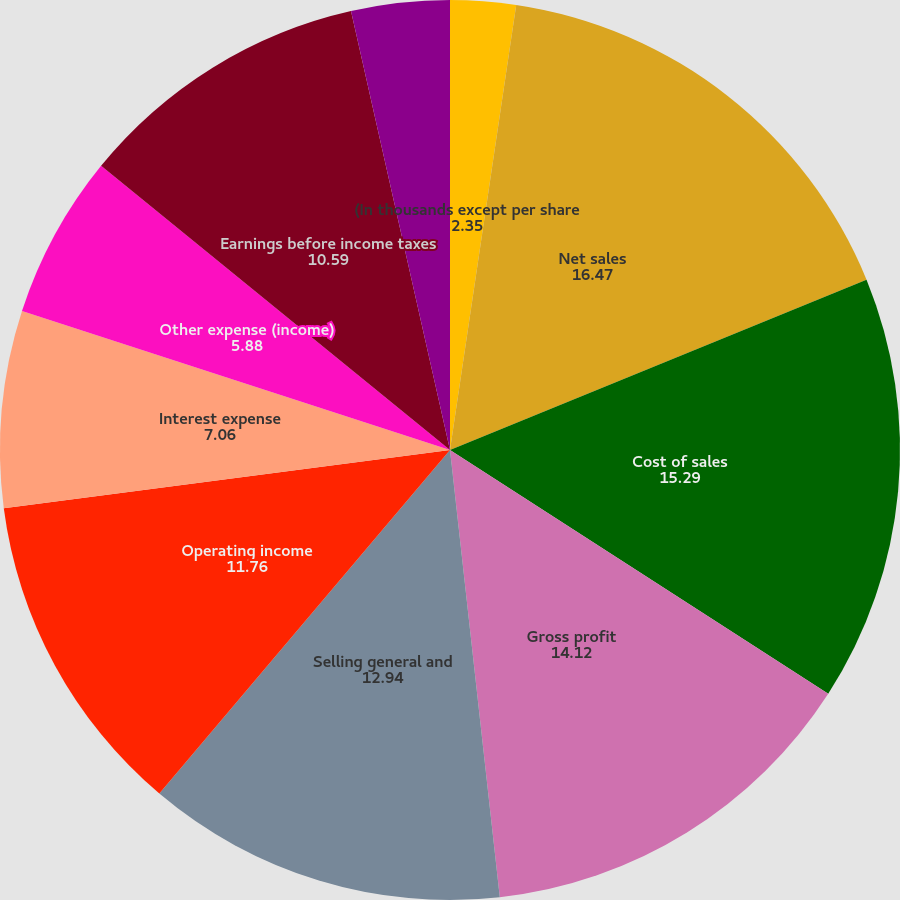Convert chart. <chart><loc_0><loc_0><loc_500><loc_500><pie_chart><fcel>(In thousands except per share<fcel>Net sales<fcel>Cost of sales<fcel>Gross profit<fcel>Selling general and<fcel>Operating income<fcel>Interest expense<fcel>Other expense (income)<fcel>Earnings before income taxes<fcel>Income tax expense<nl><fcel>2.35%<fcel>16.47%<fcel>15.29%<fcel>14.12%<fcel>12.94%<fcel>11.76%<fcel>7.06%<fcel>5.88%<fcel>10.59%<fcel>3.53%<nl></chart> 